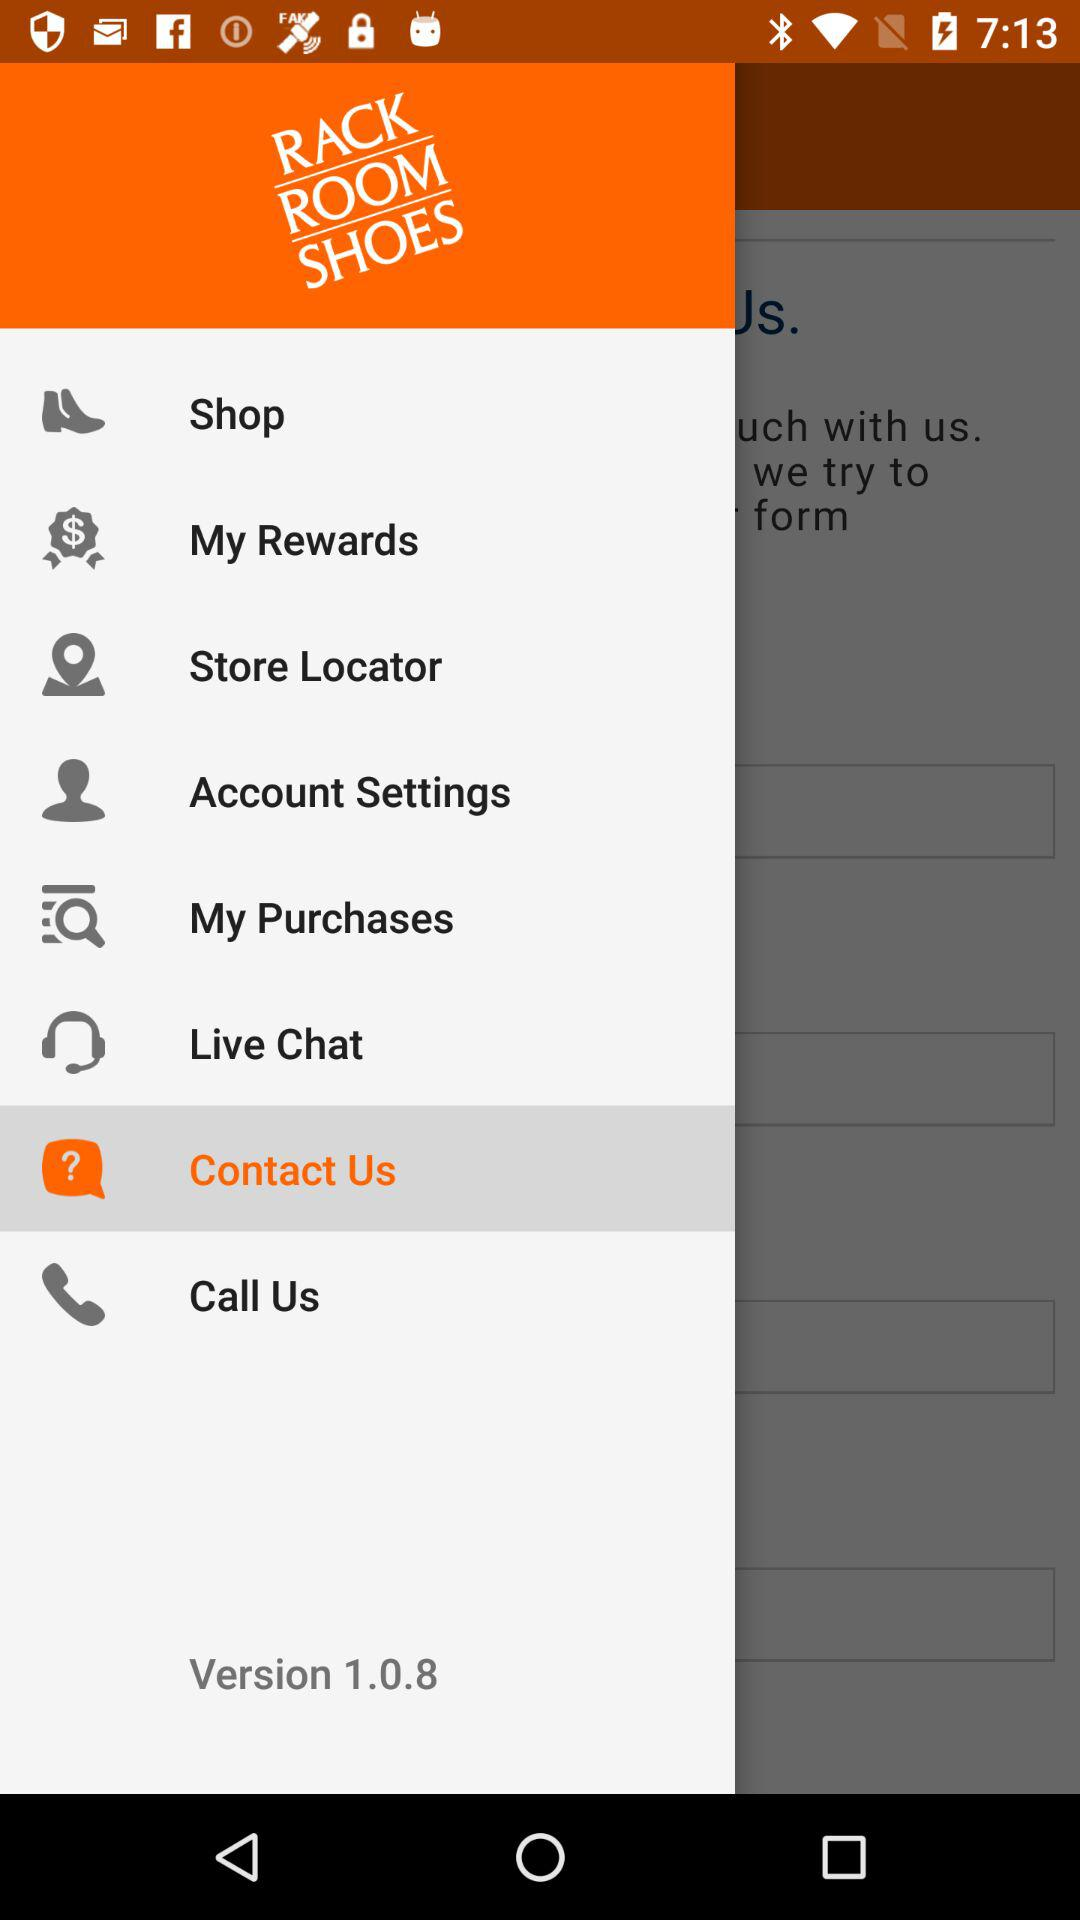What is the application name? The application name is "RACK ROOM SHOES". 